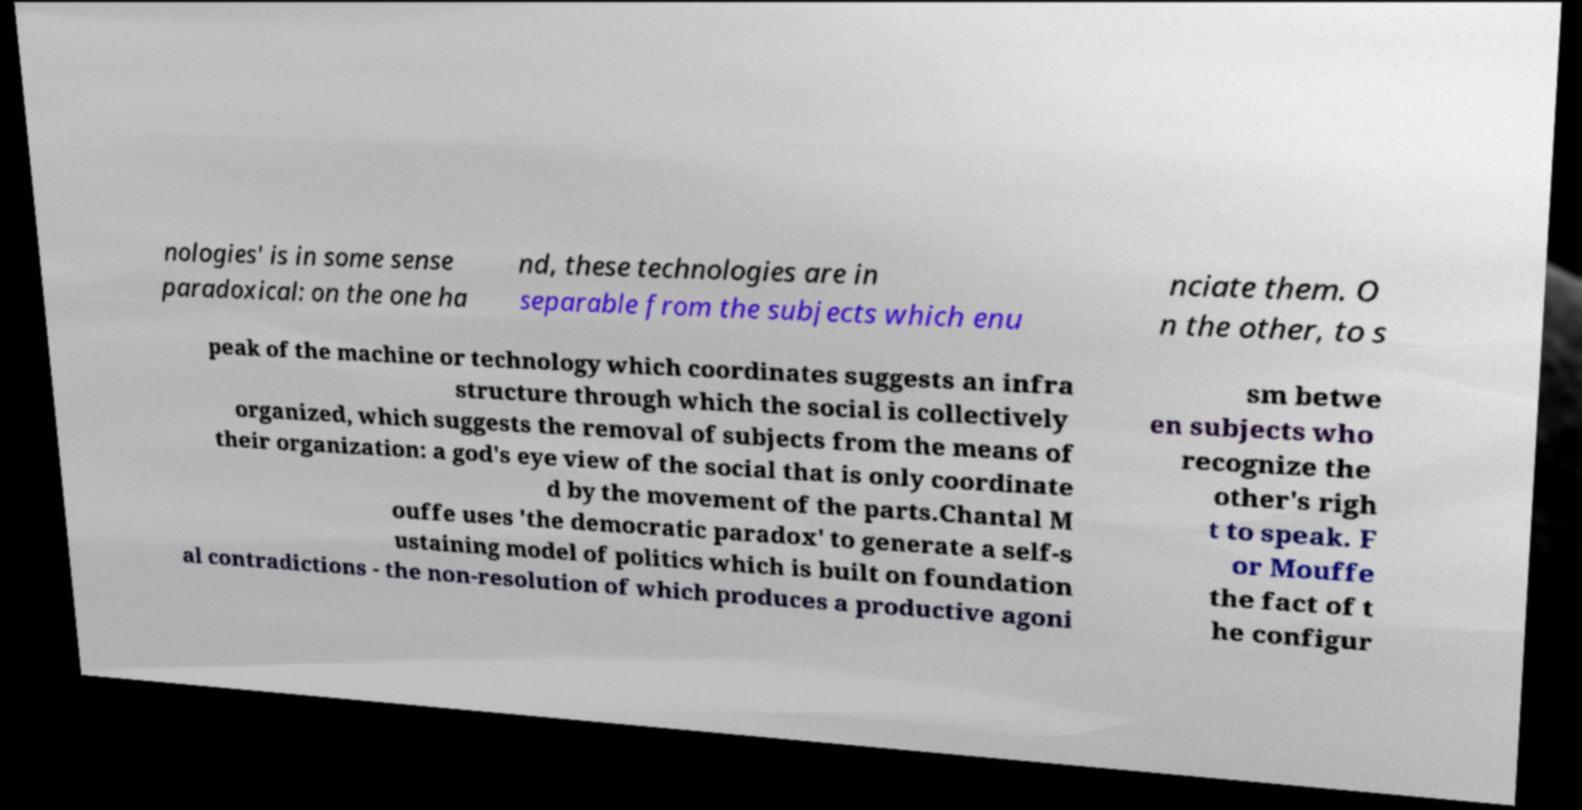Please identify and transcribe the text found in this image. nologies' is in some sense paradoxical: on the one ha nd, these technologies are in separable from the subjects which enu nciate them. O n the other, to s peak of the machine or technology which coordinates suggests an infra structure through which the social is collectively organized, which suggests the removal of subjects from the means of their organization: a god's eye view of the social that is only coordinate d by the movement of the parts.Chantal M ouffe uses 'the democratic paradox' to generate a self-s ustaining model of politics which is built on foundation al contradictions - the non-resolution of which produces a productive agoni sm betwe en subjects who recognize the other's righ t to speak. F or Mouffe the fact of t he configur 